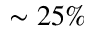<formula> <loc_0><loc_0><loc_500><loc_500>\sim 2 5 \%</formula> 